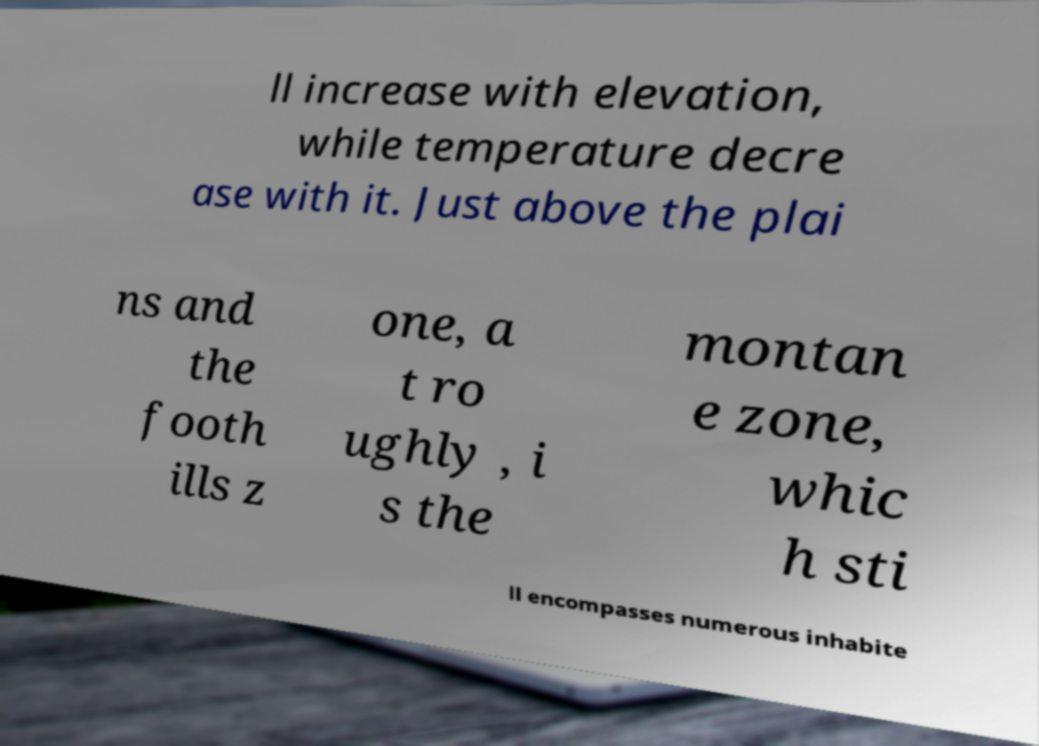Could you assist in decoding the text presented in this image and type it out clearly? ll increase with elevation, while temperature decre ase with it. Just above the plai ns and the footh ills z one, a t ro ughly , i s the montan e zone, whic h sti ll encompasses numerous inhabite 